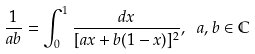Convert formula to latex. <formula><loc_0><loc_0><loc_500><loc_500>\frac { 1 } { a b } = \int _ { 0 } ^ { 1 } \frac { d x } { [ a x + b ( 1 - x ) ] ^ { 2 } } , \ a , b \in \mathbb { C }</formula> 